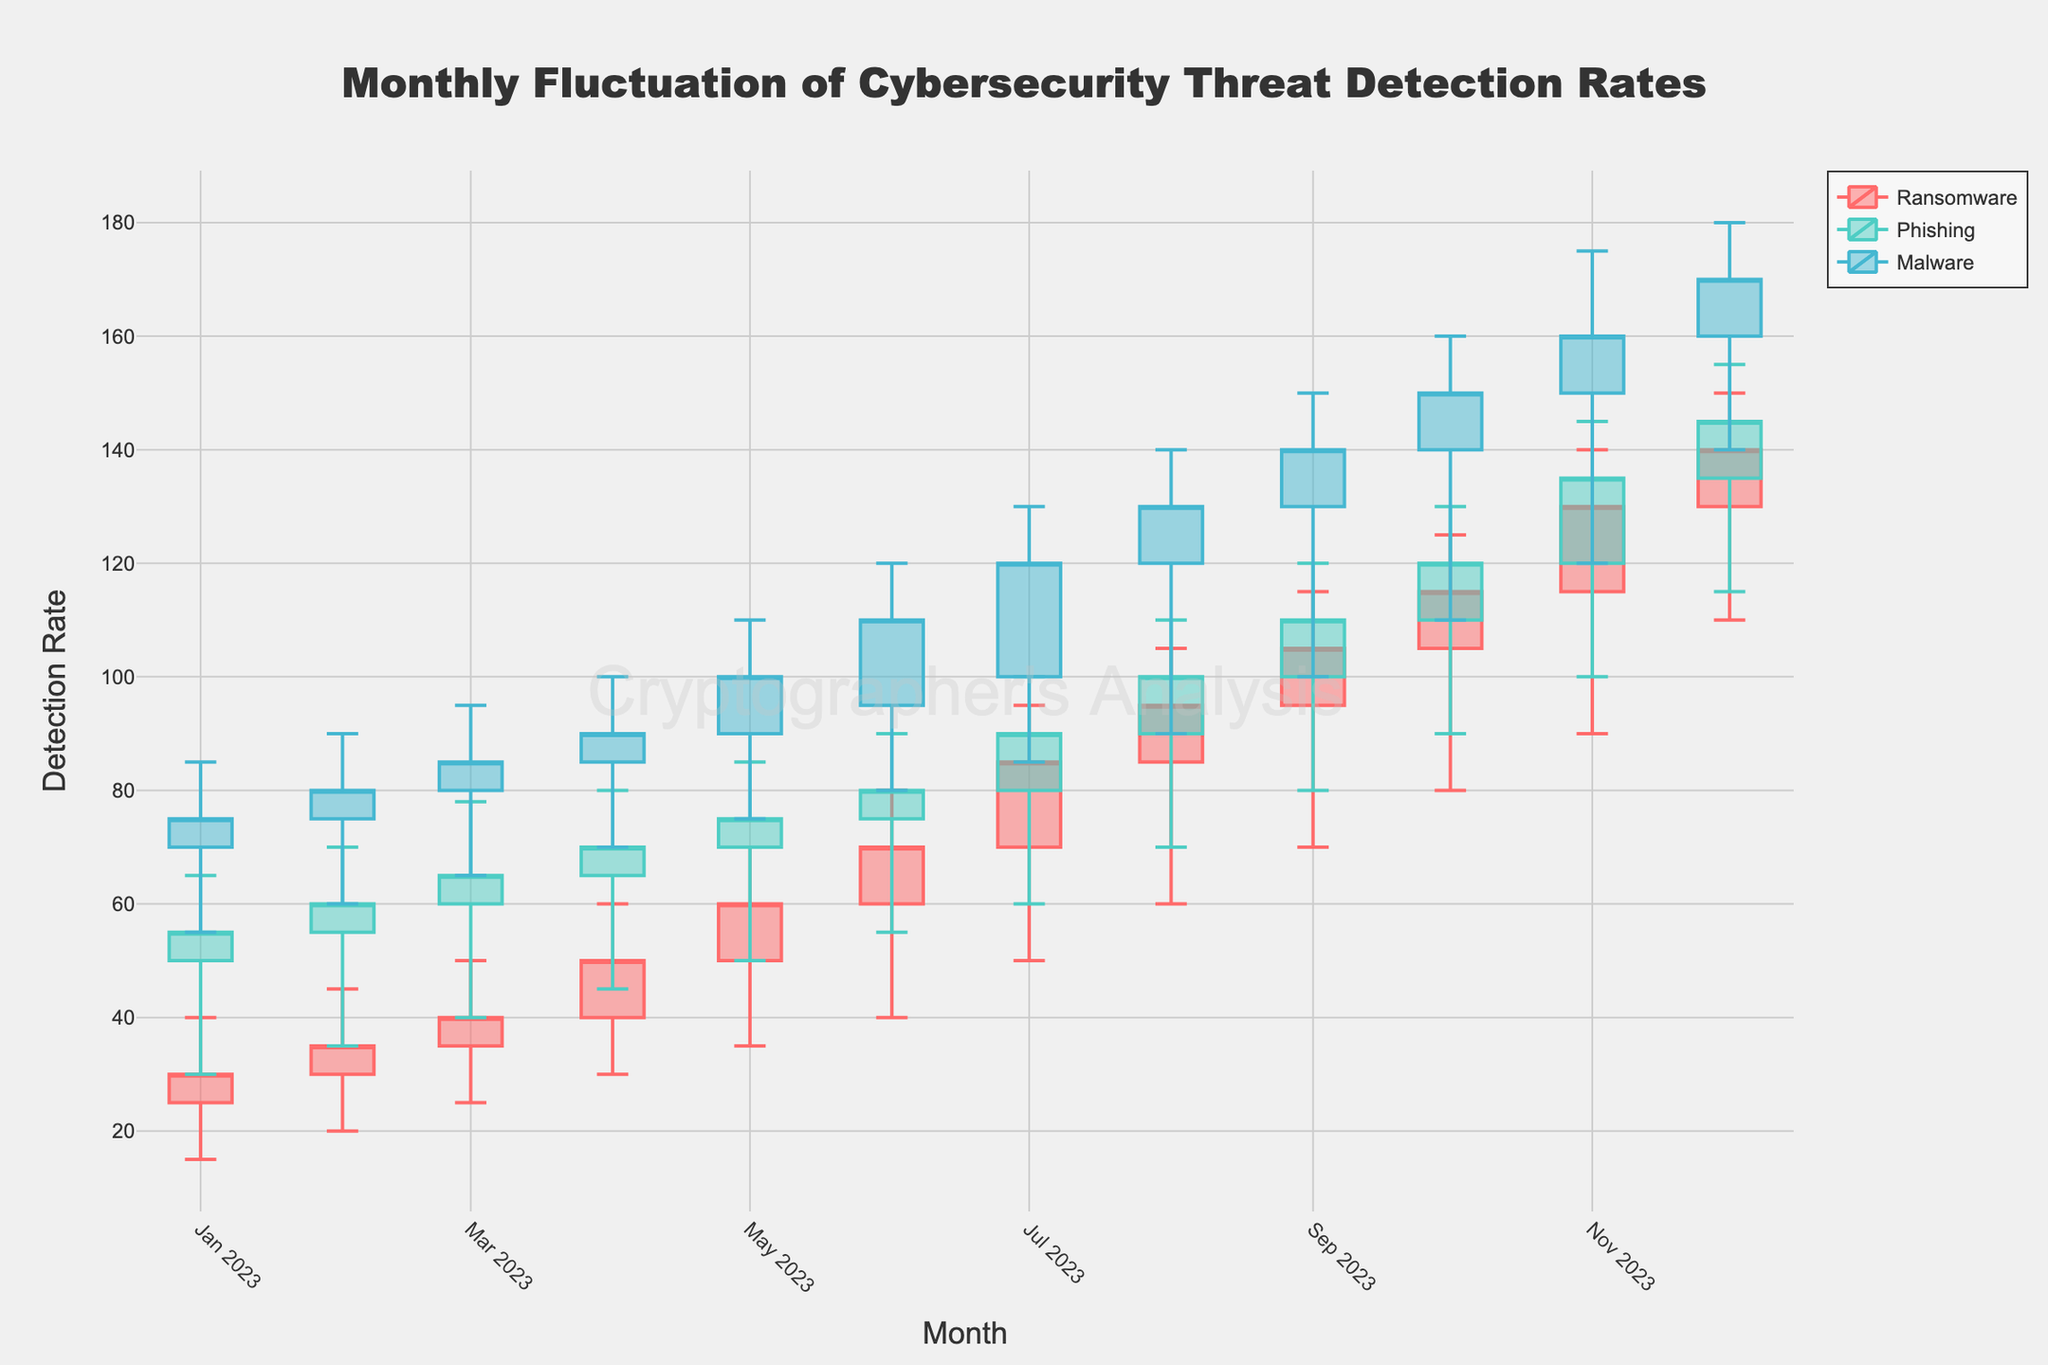What is the title of the figure? The title appears centered at the top of the figure and indicates the main subject being visualized.
Answer: Monthly Fluctuation of Cybersecurity Threat Detection Rates What is the range of detection rates for Ransomware in January 2023? Look at the candlestick for Ransomware in January 2023 and identify the lowest and highest points.
Answer: 15 to 40 Which month had the highest close value for Malware? Examine the close values for Malware across all months and determine which month had the maximum close value.
Answer: December 2023 During which month did Ransomware have the largest absolute difference between its high and low detection rates? For each month, compute the difference between the high and low values, and then compare these differences to identify the maximum.
Answer: July 2023 How does the trend in the detection rates for Phishing compare to that for Malware over the months? Examine and compare the increasing or decreasing patterns of closing values for both Phishing and Malware across all months. Phishing shows a gradual increase, while Malware has a steeper increment month by month.
Answer: Malware increases faster What similarities can you find between the detection rate trends of Ransomware and Phishing from January 2023 to March 2023? Compare the candlestick representations for Ransomware and Phishing during this period and note the trends in opening, closing, high, and low values. Both show an increasing trend in closing values over these three months.
Answer: Increasing trend 